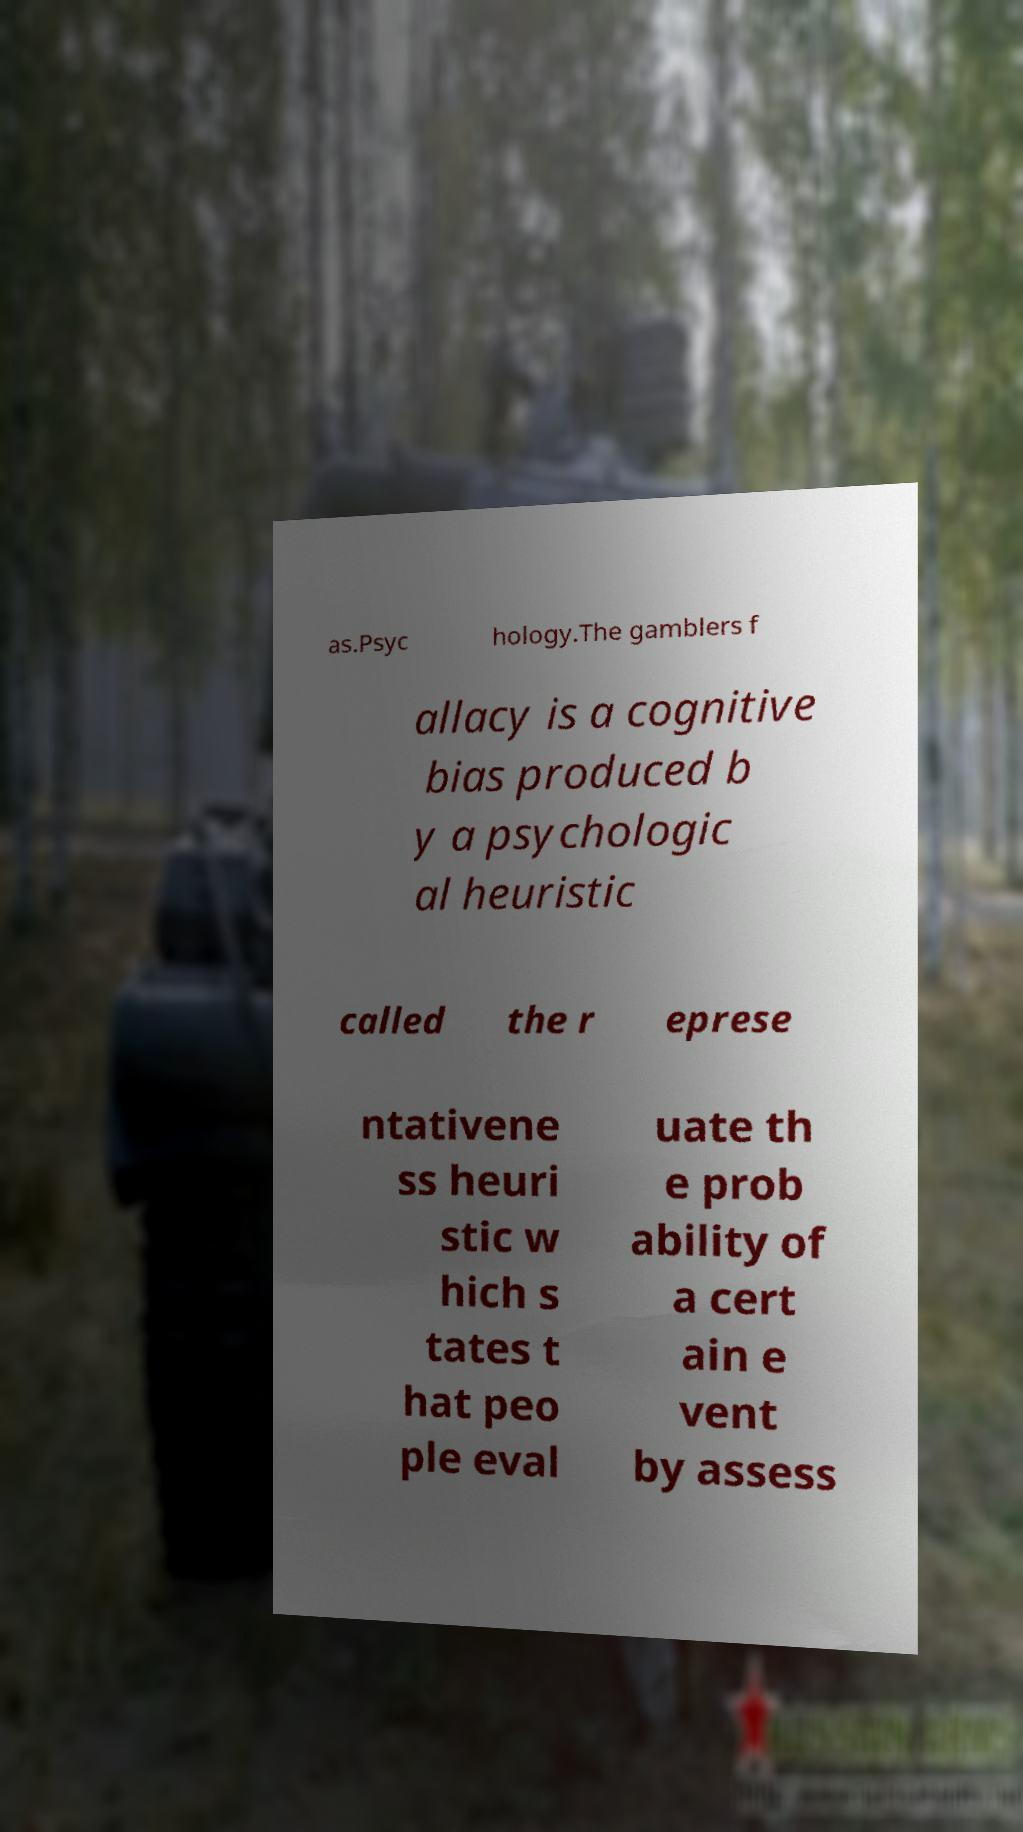Can you read and provide the text displayed in the image?This photo seems to have some interesting text. Can you extract and type it out for me? as.Psyc hology.The gamblers f allacy is a cognitive bias produced b y a psychologic al heuristic called the r eprese ntativene ss heuri stic w hich s tates t hat peo ple eval uate th e prob ability of a cert ain e vent by assess 